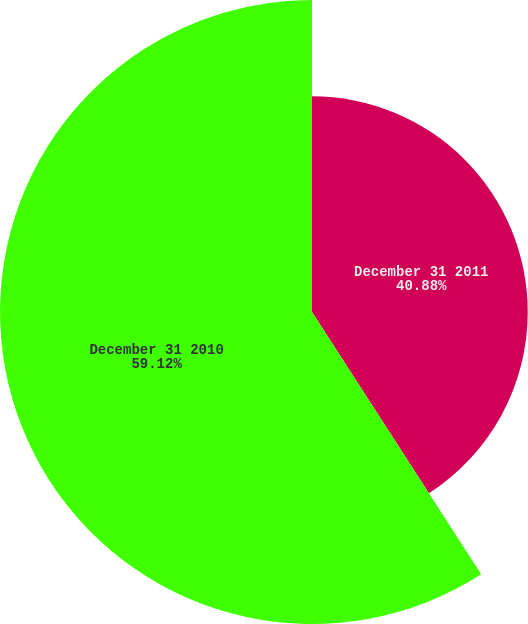Convert chart to OTSL. <chart><loc_0><loc_0><loc_500><loc_500><pie_chart><fcel>December 31 2011<fcel>December 31 2010<nl><fcel>40.88%<fcel>59.12%<nl></chart> 